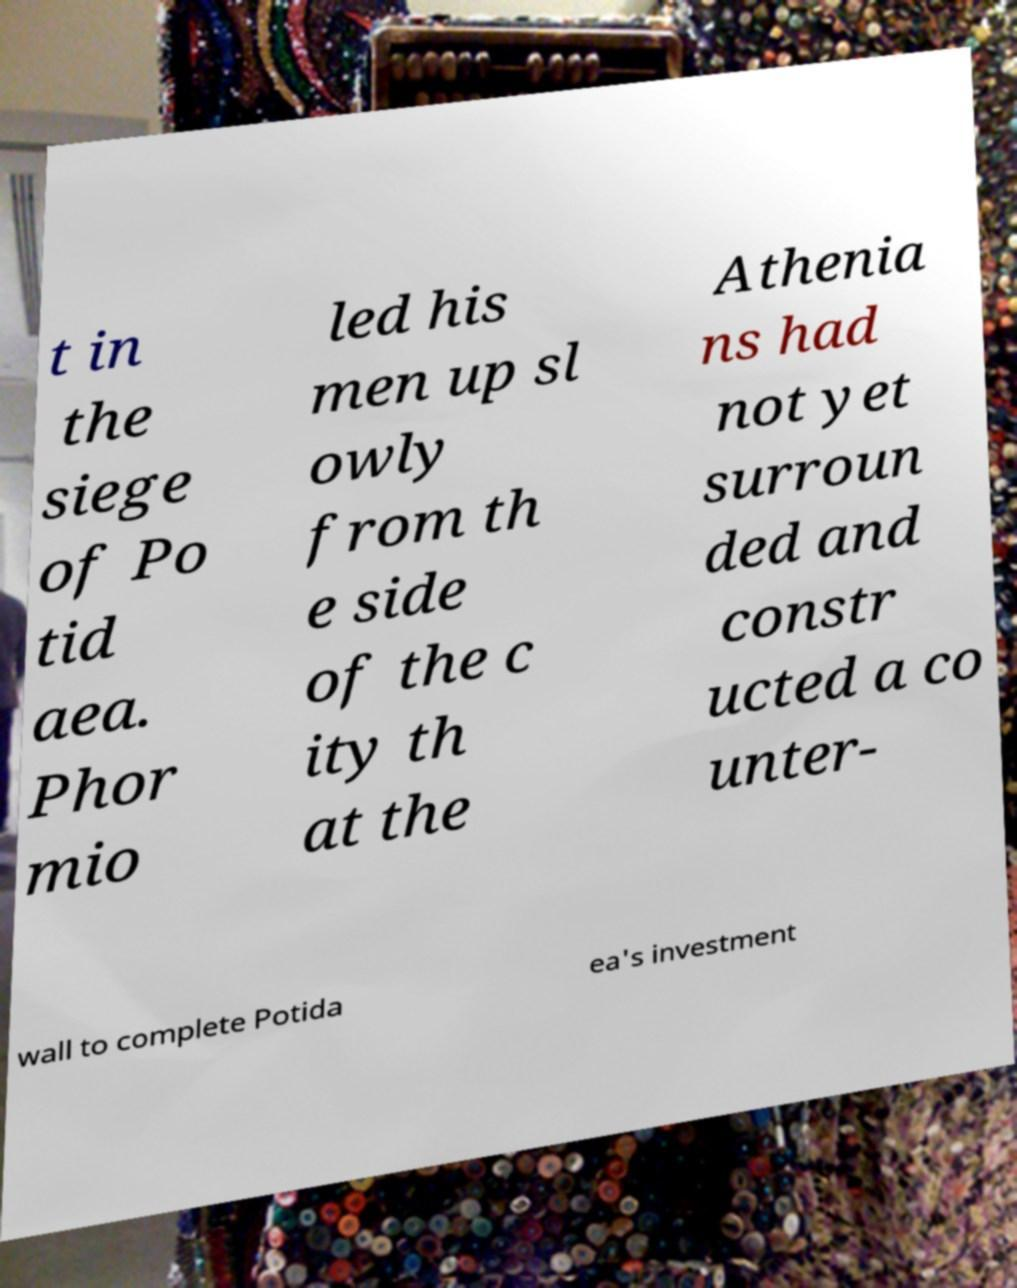Can you read and provide the text displayed in the image?This photo seems to have some interesting text. Can you extract and type it out for me? t in the siege of Po tid aea. Phor mio led his men up sl owly from th e side of the c ity th at the Athenia ns had not yet surroun ded and constr ucted a co unter- wall to complete Potida ea's investment 